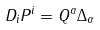Convert formula to latex. <formula><loc_0><loc_0><loc_500><loc_500>D _ { i } P ^ { i } = Q ^ { \alpha } \Delta _ { \alpha }</formula> 